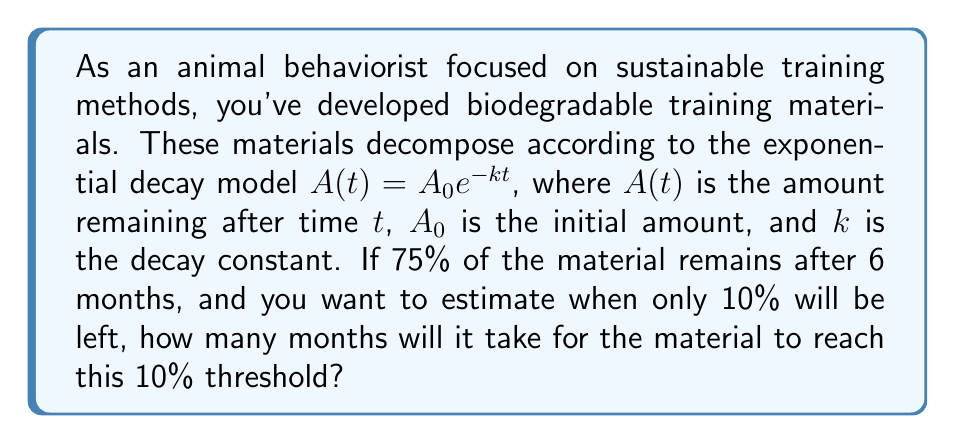What is the answer to this math problem? Let's approach this step-by-step:

1) First, we need to find the decay constant $k$ using the given information that 75% remains after 6 months:

   $0.75 = e^{-6k}$

2) Taking the natural logarithm of both sides:

   $\ln(0.75) = -6k$

3) Solving for $k$:

   $k = -\frac{\ln(0.75)}{6} \approx 0.0481$ per month

4) Now that we have $k$, we can use the exponential decay formula to find when 10% remains:

   $0.10 = e^{-kt}$

5) Taking the natural logarithm of both sides:

   $\ln(0.10) = -kt$

6) Solving for $t$:

   $t = -\frac{\ln(0.10)}{k} = -\frac{\ln(0.10)}{0.0481} \approx 47.96$ months

Therefore, it will take approximately 48 months for the material to decompose to 10% of its original amount.
Answer: Approximately 48 months 